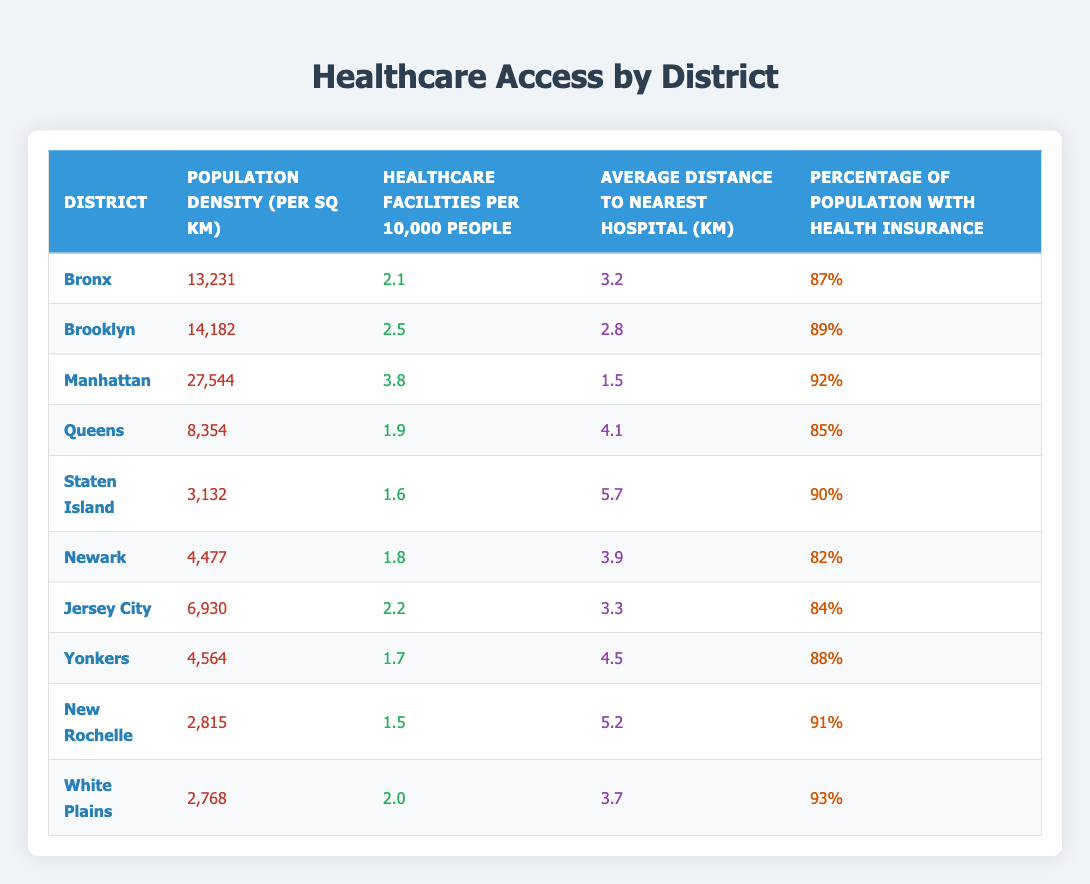What is the population density of Manhattan? The table lists Manhattan's population density directly. We look for the row corresponding to Manhattan and find the value in the "Population Density (per sq km)" column, which is 27,544.
Answer: 27,544 Which district has the highest number of healthcare facilities per 10,000 people? By scanning the "Healthcare Facilities per 10,000 People" column, we compare the values. The highest value is 3.8, found in the Manhattan row.
Answer: Manhattan Is the percentage of the population with health insurance in Queens higher than that in Newark? We check the "Percentage of Population with Health Insurance" column for both districts. Queens has 85%, while Newark has 82%. Since 85% > 82%, the answer is yes.
Answer: Yes What is the average distance to the nearest hospital for districts with a population density greater than 10,000 per sq km? First, identify districts with density > 10,000: Bronx, Brooklyn, and Manhattan. Their distances are 3.2, 2.8, and 1.5 respectively. We sum these distances (3.2 + 2.8 + 1.5 = 7.5) and divide by 3 to find the average: 7.5 / 3 = 2.5.
Answer: 2.5 Which district has the lowest average distance to the nearest hospital? By looking at the "Average Distance to Nearest Hospital (km)" column, we find that Manhattan has the lowest distance at 1.5 km.
Answer: Manhattan Do all districts have a percentage of health insurance above 80%? We check each district's percentage from the "Percentage of Population with Health Insurance" column. Every district's percentage is above 80%, confirming the statement as true.
Answer: Yes How many healthcare facilities are in Bronx if we consider a population of 100,000? From the "Healthcare Facilities per 10,000 People" for Bronx, which is 2.1, we calculate as follows: (100,000 / 10,000) * 2.1 = 21.
Answer: 21 What is the difference in population density between Brooklyn and Staten Island? We find the densities from the table: Brooklyn's density is 14,182 and Staten Island's is 3,132. The difference is calculated as 14,182 - 3,132 = 11,050.
Answer: 11,050 Is the healthcare access in Newark better than that in Queens based on healthcare facilities per 10,000 people? By comparing the two values, Newark has 1.8 while Queens has 1.9. Since 1.8 is less than 1.9, Newark does not have better access than Queens.
Answer: No 